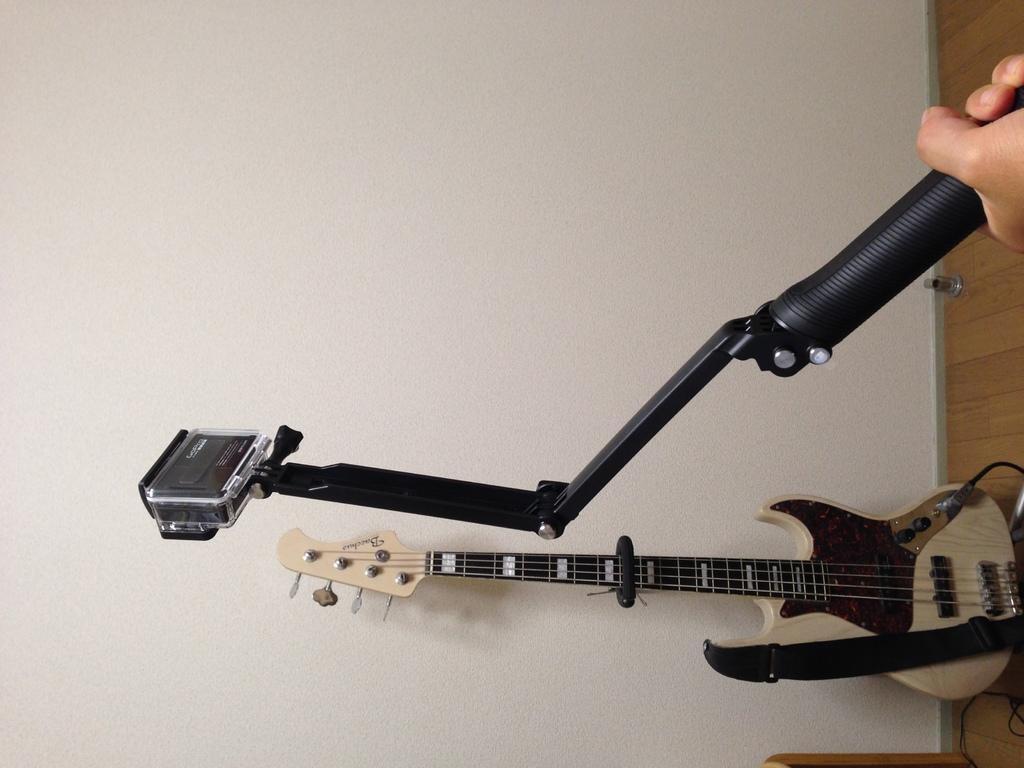Describe this image in one or two sentences. In this image I can see a guitar which is cream in color attached to the wall. This looks like a stand which is black in color holded by a person in his hand. This is the wooden floor. this is the wall. 